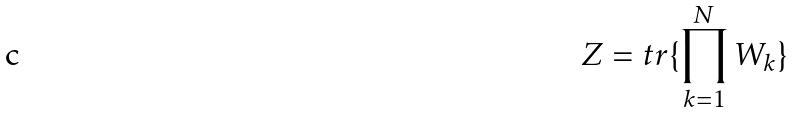<formula> <loc_0><loc_0><loc_500><loc_500>Z = t r \{ \prod _ { k = 1 } ^ { N } W _ { k } \}</formula> 